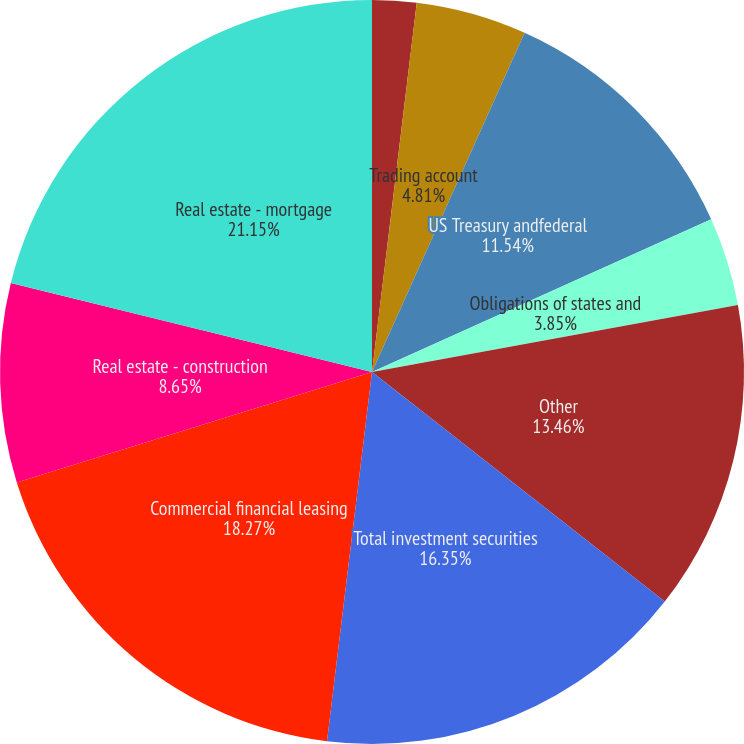Convert chart. <chart><loc_0><loc_0><loc_500><loc_500><pie_chart><fcel>Interest-bearing deposits at<fcel>Federalfundssold<fcel>Trading account<fcel>US Treasury andfederal<fcel>Obligations of states and<fcel>Other<fcel>Total investment securities<fcel>Commercial financial leasing<fcel>Real estate - construction<fcel>Real estate - mortgage<nl><fcel>0.0%<fcel>1.92%<fcel>4.81%<fcel>11.54%<fcel>3.85%<fcel>13.46%<fcel>16.35%<fcel>18.27%<fcel>8.65%<fcel>21.15%<nl></chart> 